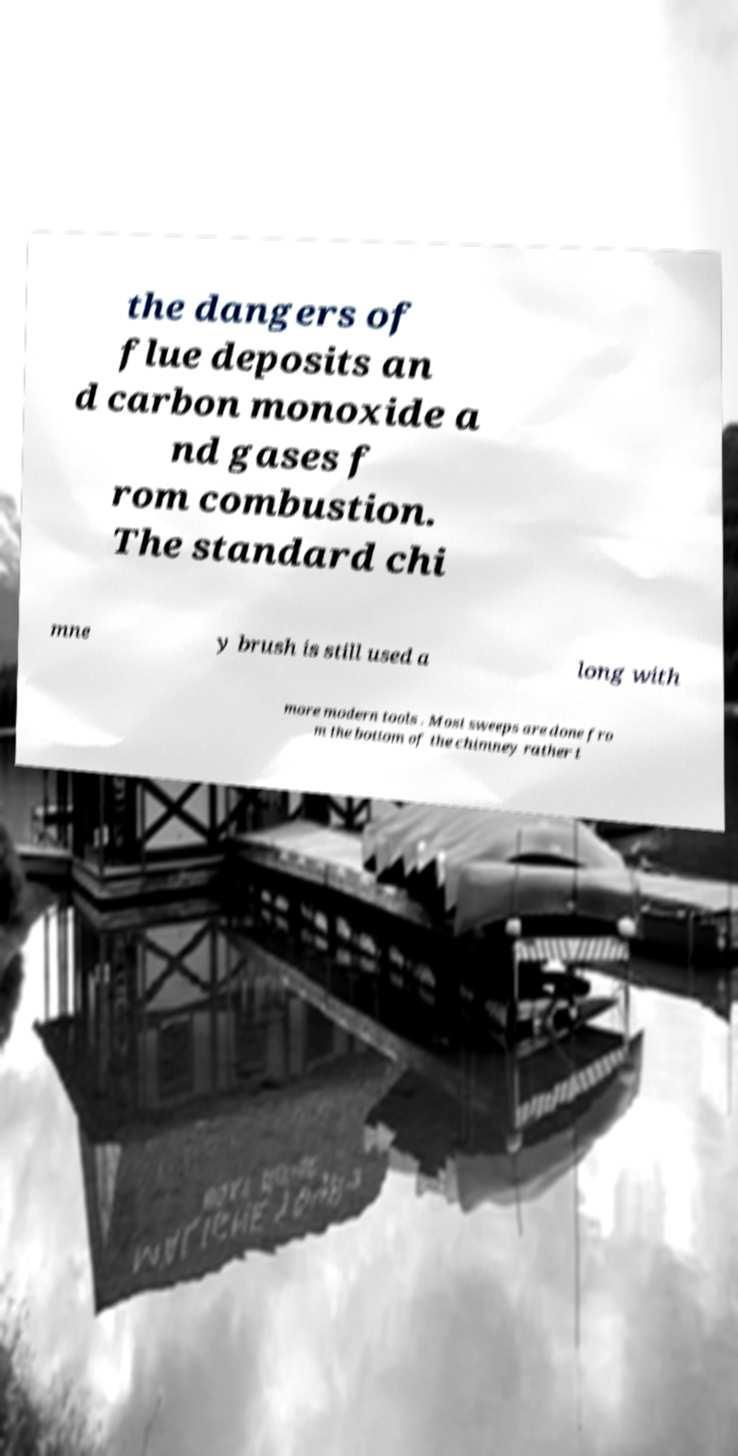Can you accurately transcribe the text from the provided image for me? the dangers of flue deposits an d carbon monoxide a nd gases f rom combustion. The standard chi mne y brush is still used a long with more modern tools . Most sweeps are done fro m the bottom of the chimney rather t 